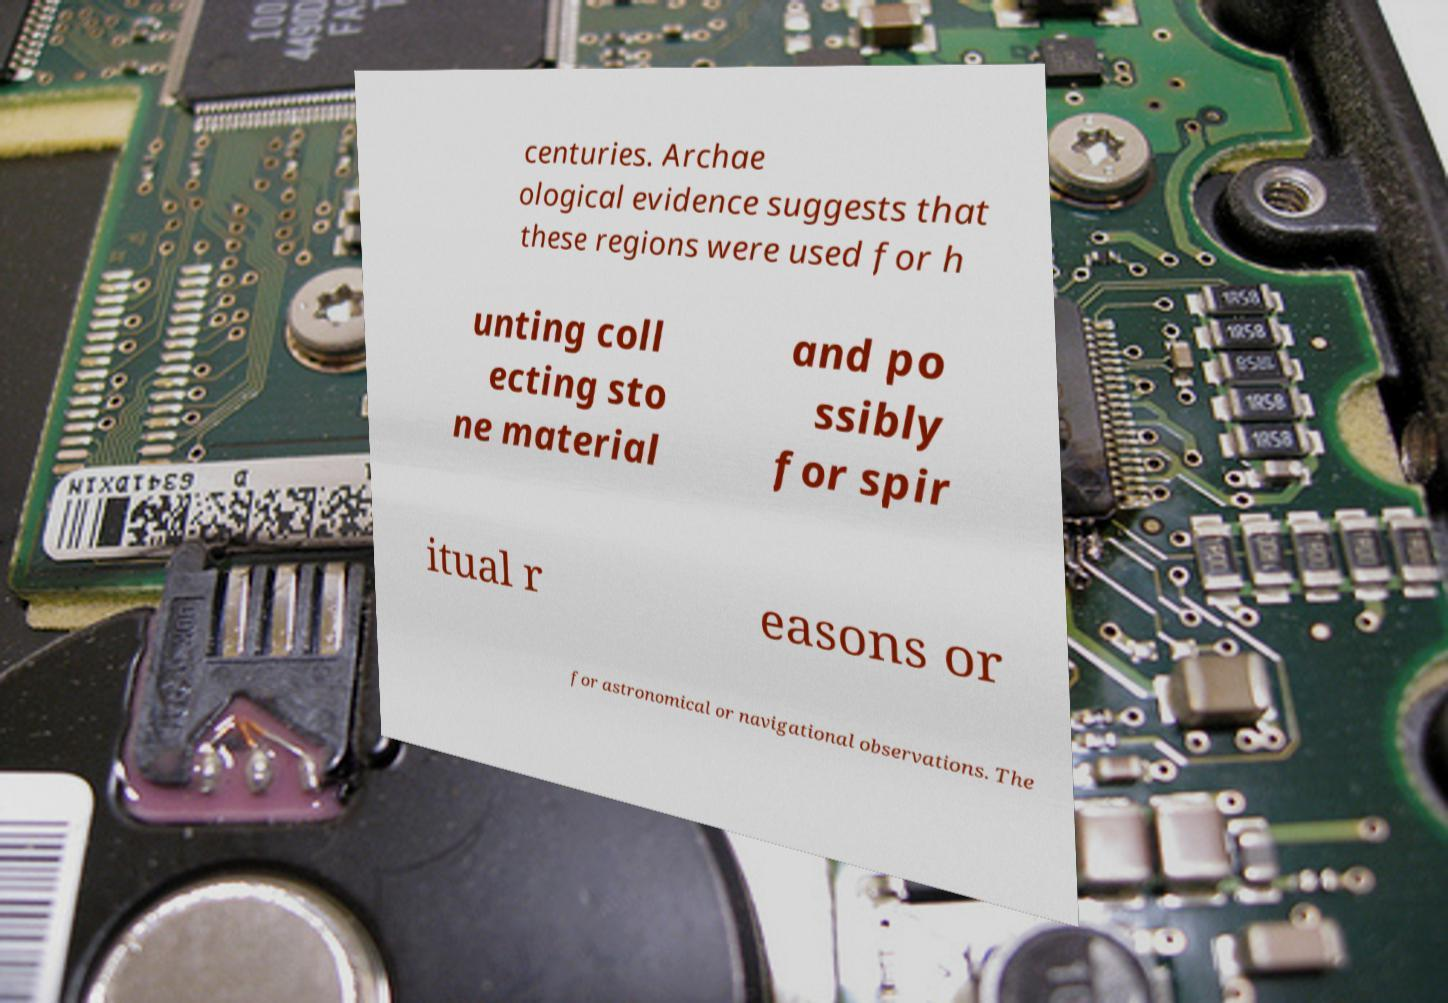What messages or text are displayed in this image? I need them in a readable, typed format. centuries. Archae ological evidence suggests that these regions were used for h unting coll ecting sto ne material and po ssibly for spir itual r easons or for astronomical or navigational observations. The 